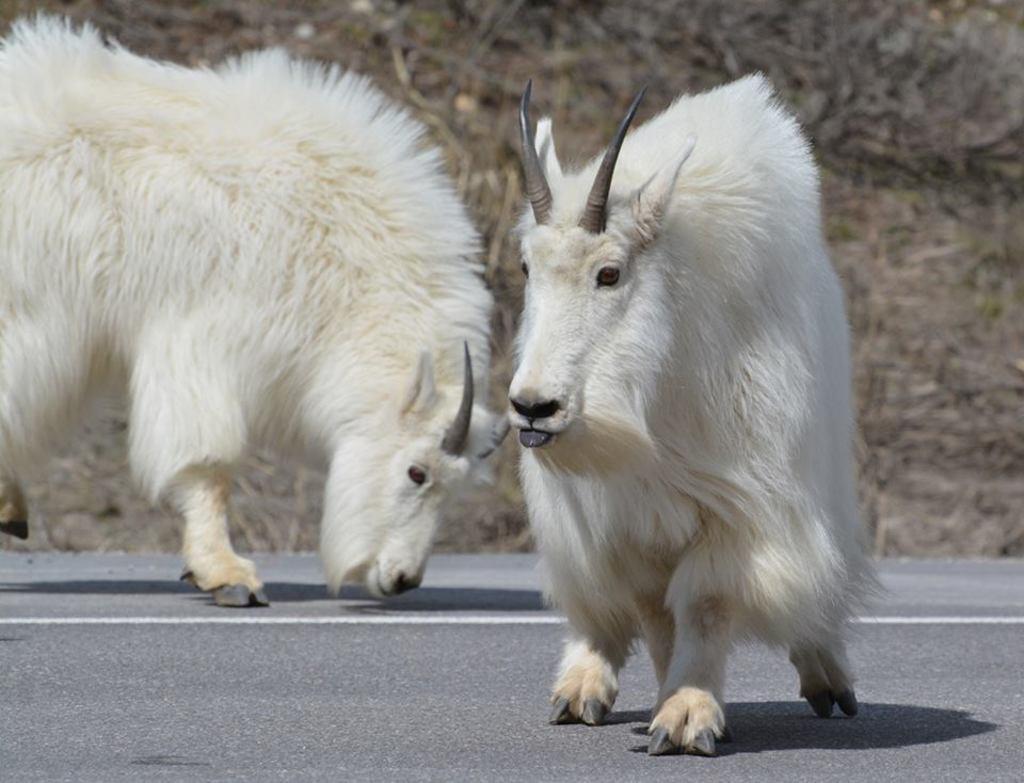How would you summarize this image in a sentence or two? In this image we can see two animals on the road, some bushes and grass on the surface. 